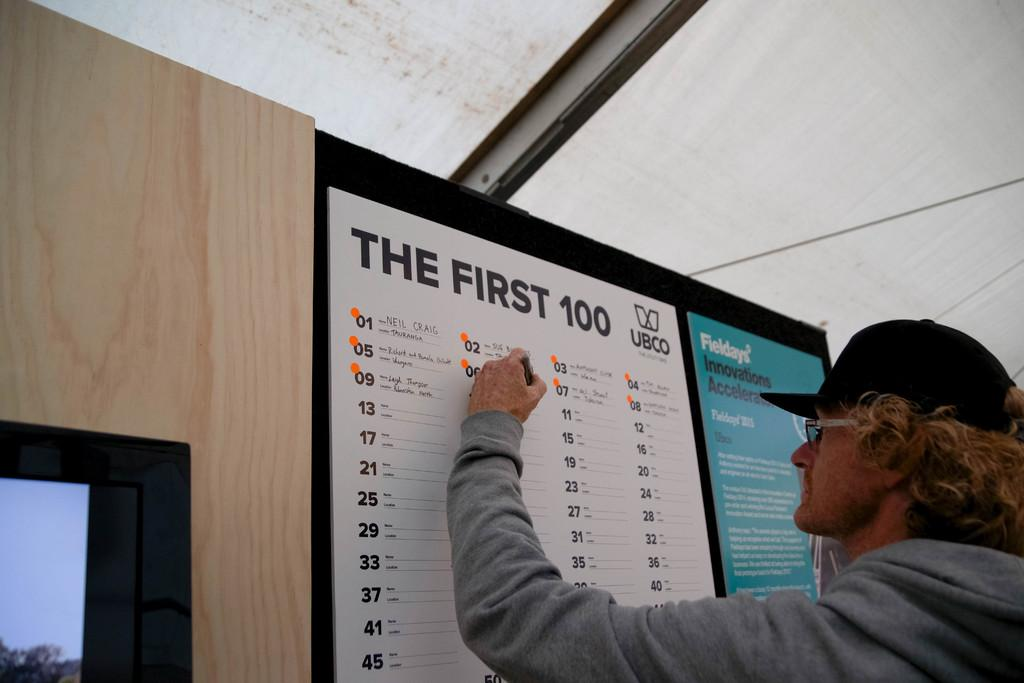Provide a one-sentence caption for the provided image. A man is signing his name on a chart on the wall for the first 100 UBCO, with Fieldays Innovations Accelerator on it on the right side. 